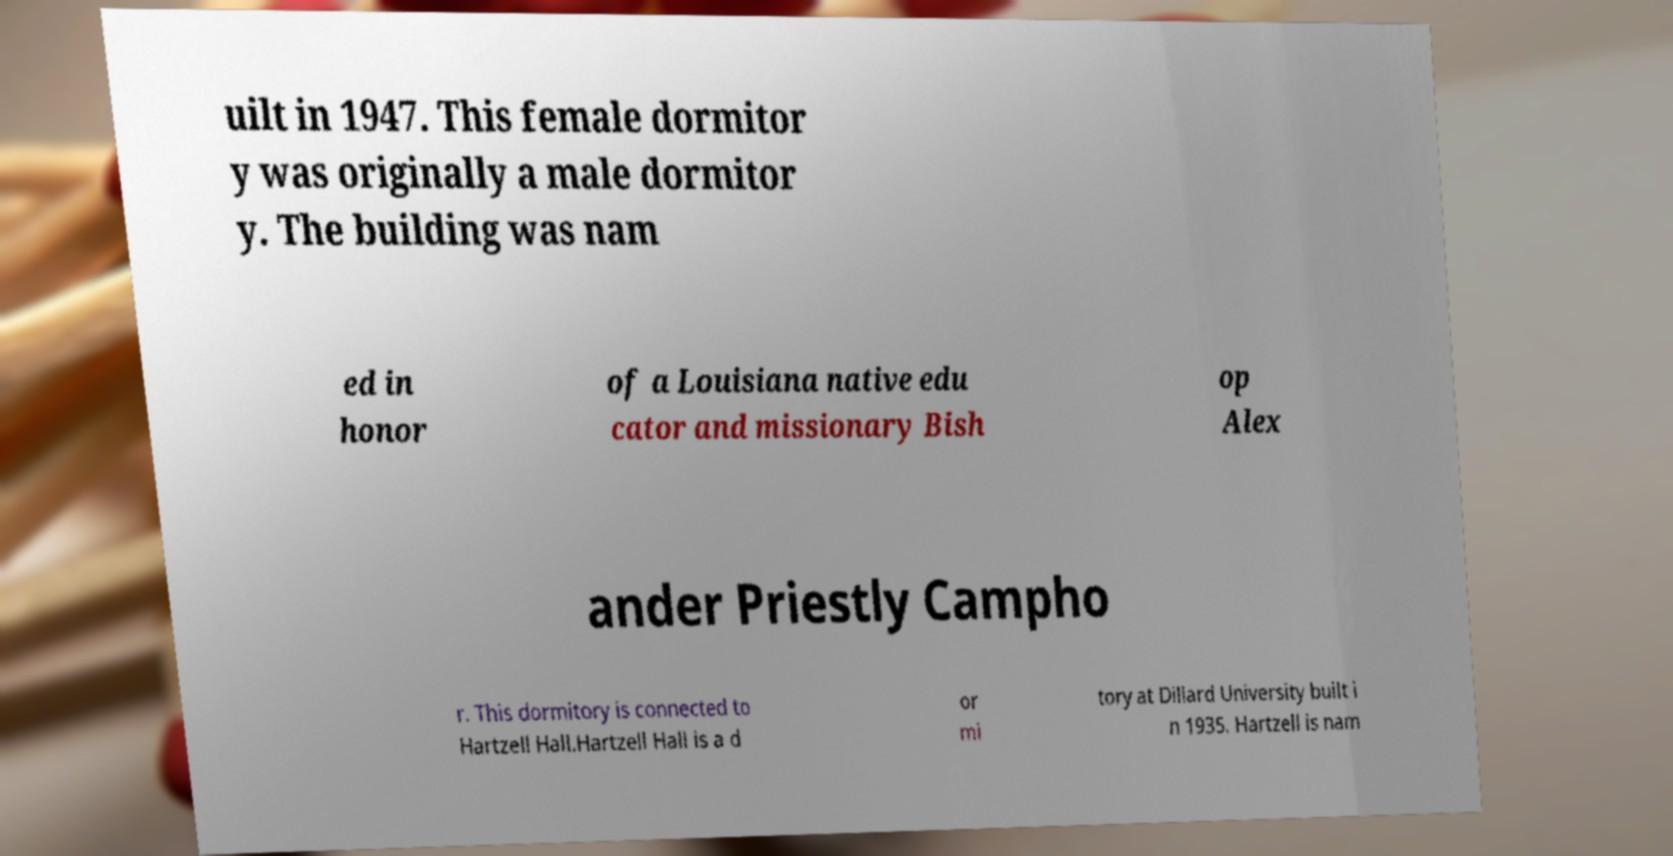What messages or text are displayed in this image? I need them in a readable, typed format. uilt in 1947. This female dormitor y was originally a male dormitor y. The building was nam ed in honor of a Louisiana native edu cator and missionary Bish op Alex ander Priestly Campho r. This dormitory is connected to Hartzell Hall.Hartzell Hall is a d or mi tory at Dillard University built i n 1935. Hartzell is nam 